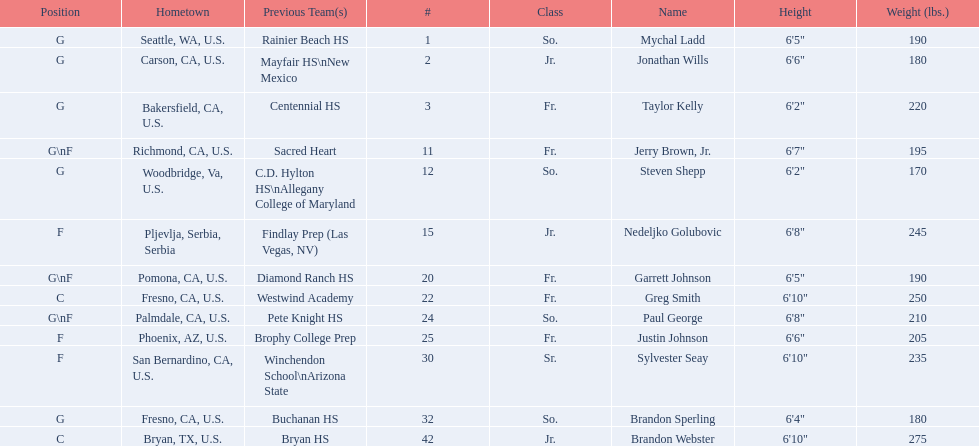How many players and both guard (g) and forward (f)? 3. 